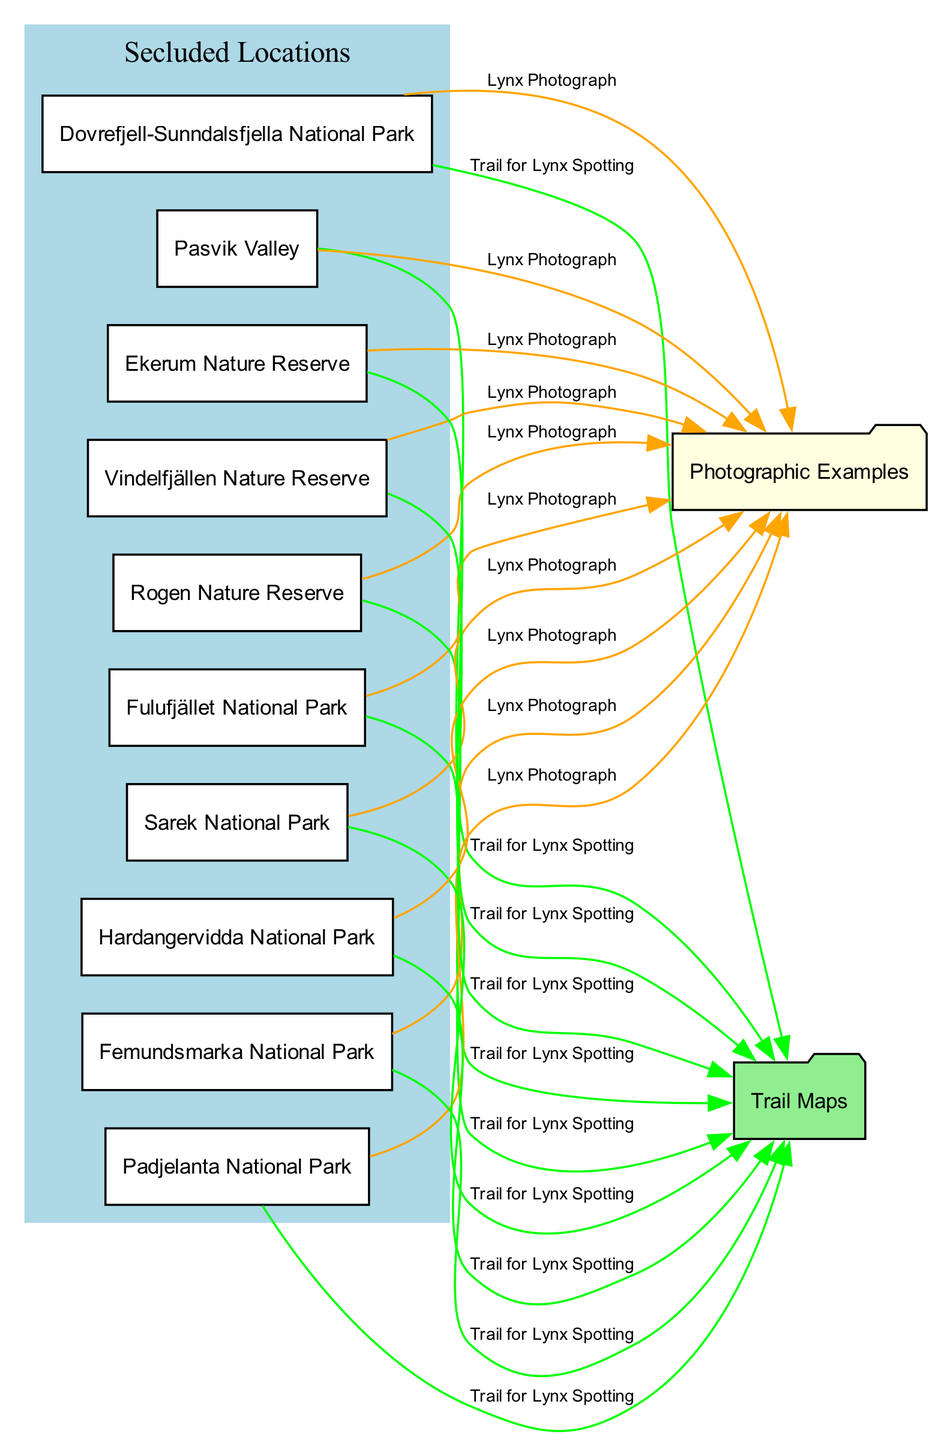What is the first location listed for lynx spotting? By looking at the nodes in the diagram, the first location node is "Dovrefjell-Sunndalsfjella National Park," which is positioned first in the list of locations, indicating its top placement for lynx spotting.
Answer: Dovrefjell-Sunndalsfjella National Park How many total locations are identified for lynx spotting in the diagram? The diagram contains ten nodes that represent specific locations for lynx spotting. By counting each location node within the "Secluded Locations" section, we confirm that there are ten distinct locations.
Answer: 10 Which location is associated with the trail map? Each of the location nodes is connected to the "Trail Map" node through labeled edges. By examining these connections, we can conclude that each one has trails for lynx spotting leading to the trail map node. The first mentioned location, “Dovrefjell-Sunndalsfjella National Park,” serves as a representative example of locations connected to the trail map.
Answer: Dovrefjell-Sunndalsfjella National Park How many edges connect to the “Photographic Examples” section? There are ten edges connecting different locations to the "Photographic Examples" node. Each edge shows a relationship between each location and the photographic examples, demonstrating that all locations have corresponding photographs.
Answer: 10 Which location comes after “Fulufjället National Park” in the list? In the list of locations, "Rogen Nature Reserve" comes directly after "Fulufjället National Park." By reviewing the sequential order of the location nodes, we can determine that the next one listed follows directly after Fulufjället.
Answer: Rogen Nature Reserve Which two locations do not connect to the "Trail Map"? All ten locations are connected to the "Trail Map" node with edges indicating trails for lynx spotting. Since all locations have trails, none of them are excluded from connecting to the "Trail Map." Thus, there are actually no locations that do not connect.
Answer: None Identify the color used for the "Trail Maps" node. The "Trail Maps" node is indicated with a light green fill color in the diagram. By observing the color attribute assigned to that specific node, we can identify its color.
Answer: Light green Which two edges are colored green in the diagram? All edges that connect each location to the "Trail Map" are colored green. This includes edges from all ten locations indicating their trail connections.
Answer: All edges from locations to "Trail Map" 